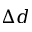<formula> <loc_0><loc_0><loc_500><loc_500>\Delta d</formula> 